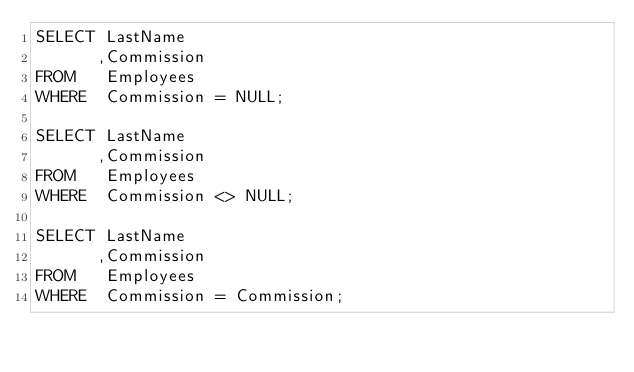<code> <loc_0><loc_0><loc_500><loc_500><_SQL_>SELECT LastName
      ,Commission
FROM   Employees
WHERE  Commission = NULL;

SELECT LastName
      ,Commission
FROM   Employees
WHERE  Commission <> NULL;

SELECT LastName
      ,Commission
FROM   Employees
WHERE  Commission = Commission;
</code> 